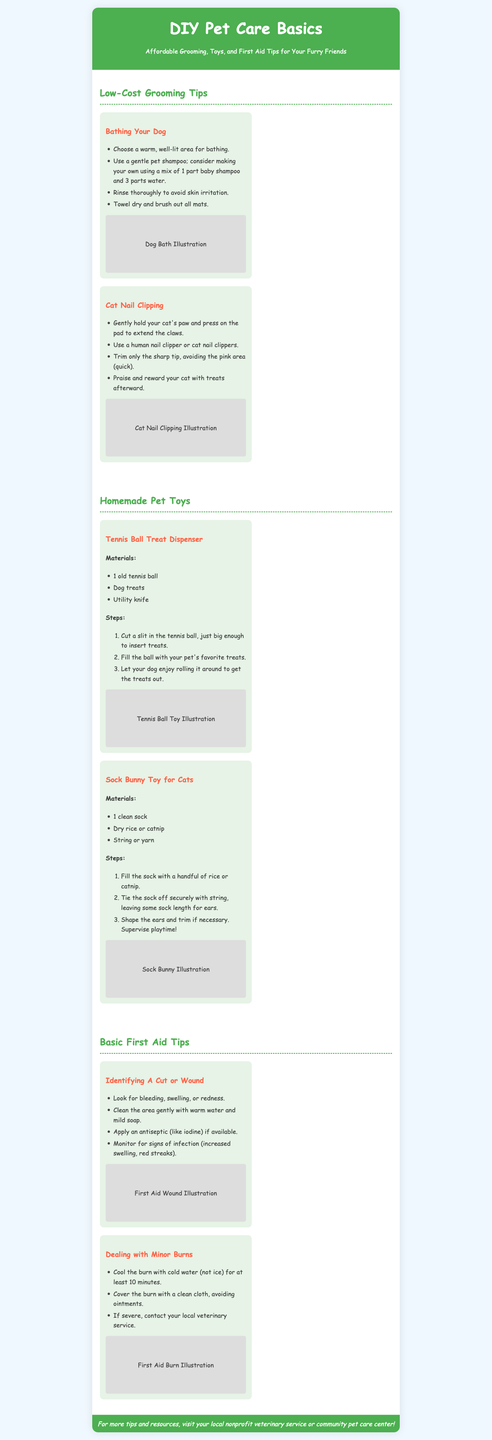what are the two main sections in the grooming tips? The grooming tips section includes "Bathing Your Dog" and "Cat Nail Clipping."
Answer: Bathing Your Dog, Cat Nail Clipping how do you make dog shampoo at home? The document suggests mixing 1 part baby shampoo and 3 parts water to create a gentle pet shampoo.
Answer: 1 part baby shampoo and 3 parts water what materials do you need for the Tennis Ball Treat Dispenser? The materials listed for the Tennis Ball Treat Dispenser are an old tennis ball, dog treats, and a utility knife.
Answer: Old tennis ball, dog treats, utility knife what should you do if you identify a cut or wound on your pet? If a cut or wound is identified, you should clean the area gently with warm water and mild soap, and apply antiseptic if available.
Answer: Clean with warm water and mild soap what is a fun toy you can make for a cat from a sock? A fun toy you can make is a "Sock Bunny Toy" filled with dry rice or catnip.
Answer: Sock Bunny Toy how long should you cool a minor burn with cold water? It's recommended to cool the burn for at least 10 minutes with cold water.
Answer: 10 minutes why is it important to monitor a pet wound after cleaning? It is important to monitor a pet wound for signs of infection, such as increased swelling or red streaks.
Answer: Signs of infection what is the visual representation used in the brochure for each section? Each section includes illustrations to visually represent the tips and activities described.
Answer: Illustrations 